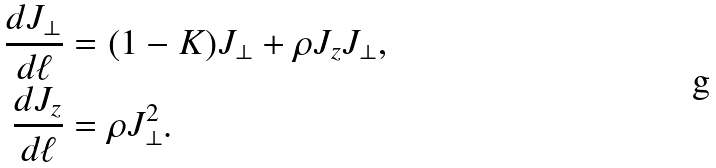Convert formula to latex. <formula><loc_0><loc_0><loc_500><loc_500>\frac { d J _ { \perp } } { d \ell } & = ( 1 - K ) J _ { \perp } + \rho J _ { z } J _ { \perp } , \\ \frac { d J _ { z } } { d \ell } & = \rho J _ { \perp } ^ { 2 } .</formula> 